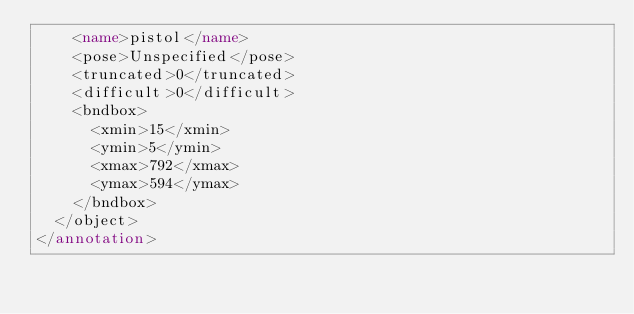<code> <loc_0><loc_0><loc_500><loc_500><_XML_>    <name>pistol</name>
    <pose>Unspecified</pose>
    <truncated>0</truncated>
    <difficult>0</difficult>
    <bndbox>
      <xmin>15</xmin>
      <ymin>5</ymin>
      <xmax>792</xmax>
      <ymax>594</ymax>
    </bndbox>
  </object>
</annotation>
</code> 